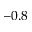<formula> <loc_0><loc_0><loc_500><loc_500>- 0 . 8</formula> 